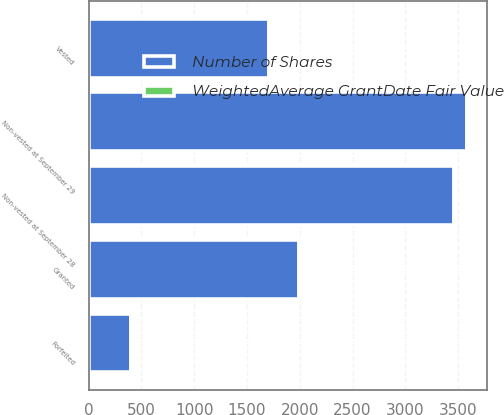<chart> <loc_0><loc_0><loc_500><loc_500><stacked_bar_chart><ecel><fcel>Non-vested at September 29<fcel>Granted<fcel>Vested<fcel>Forfeited<fcel>Non-vested at September 28<nl><fcel>Number of Shares<fcel>3580<fcel>1995<fcel>1711<fcel>405<fcel>3459<nl><fcel>WeightedAverage GrantDate Fair Value<fcel>16.45<fcel>19.94<fcel>15.98<fcel>18.11<fcel>18.51<nl></chart> 